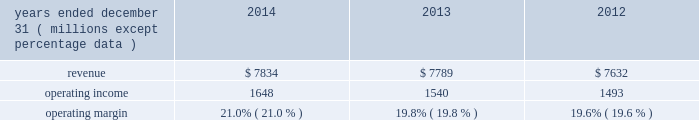Equity equity at december 31 , 2014 was $ 6.6 billion , a decrease of $ 1.6 billion from december 31 , 2013 .
The decrease resulted primarily due to share repurchases of $ 2.3 billion , $ 273 million of dividends to shareholders , and an increase in accumulated other comprehensive loss of $ 760 million , partially offset by net income of $ 1.4 billion .
The $ 760 million increase in accumulated other comprehensive loss from december 31 , 2013 , primarily reflects the following : 2022 negative net foreign currency translation adjustments of $ 504 million , which are attributable to the strengthening of the u.s .
Dollar against certain foreign currencies , 2022 an increase of $ 260 million in net post-retirement benefit obligations , 2022 net derivative gains of $ 5 million , and 2022 net investment losses of $ 1 million .
Review by segment general we serve clients through the following segments : 2022 risk solutions acts as an advisor and insurance and reinsurance broker , helping clients manage their risks , via consultation , as well as negotiation and placement of insurance risk with insurance carriers through our global distribution network .
2022 hr solutions partners with organizations to solve their most complex benefits , talent and related financial challenges , and improve business performance by designing , implementing , communicating and administering a wide range of human capital , retirement , investment management , health care , compensation and talent management strategies .
Risk solutions .
The demand for property and casualty insurance generally rises as the overall level of economic activity increases and generally falls as such activity decreases , affecting both the commissions and fees generated by our brokerage business .
The economic activity that impacts property and casualty insurance is described as exposure units , and is most closely correlated with employment levels , corporate revenue and asset values .
During 2014 , pricing was flat on average globally , and we would still consider this to be a "soft market." in a soft market , premium rates flatten or decrease , along with commission revenues , due to increased competition for market share among insurance carriers or increased underwriting capacity .
Changes in premiums have a direct and potentially material impact on the insurance brokerage industry , as commission revenues are generally based on a percentage of the premiums paid by insureds .
Additionally , continuing through 2014 , we faced difficult conditions as a result of continued weakness in the global economy , the repricing of credit risk and the deterioration of the financial markets .
Weak economic conditions in many markets around the globe have reduced our customers' demand for our retail brokerage and reinsurance brokerage products , which have had a negative impact on our operational results .
Risk solutions generated approximately 65% ( 65 % ) of our consolidated total revenues in 2014 .
Revenues are generated primarily through fees paid by clients , commissions and fees paid by insurance and reinsurance companies , and investment income on funds held on behalf of clients .
Our revenues vary from quarter to quarter throughout the year as a result of the timing of our clients' policy renewals , the net effect of new and lost business , the timing of services provided to our clients , and the income we earn on investments , which is heavily influenced by short-term interest rates .
We operate in a highly competitive industry and compete with many retail insurance brokerage and agency firms , as well as with individual brokers , agents , and direct writers of insurance coverage .
Specifically , we address the highly specialized .
What is the growth rate of revenue from 2013 to 2014? 
Computations: ((7834 - 7789) / 7789)
Answer: 0.00578. 